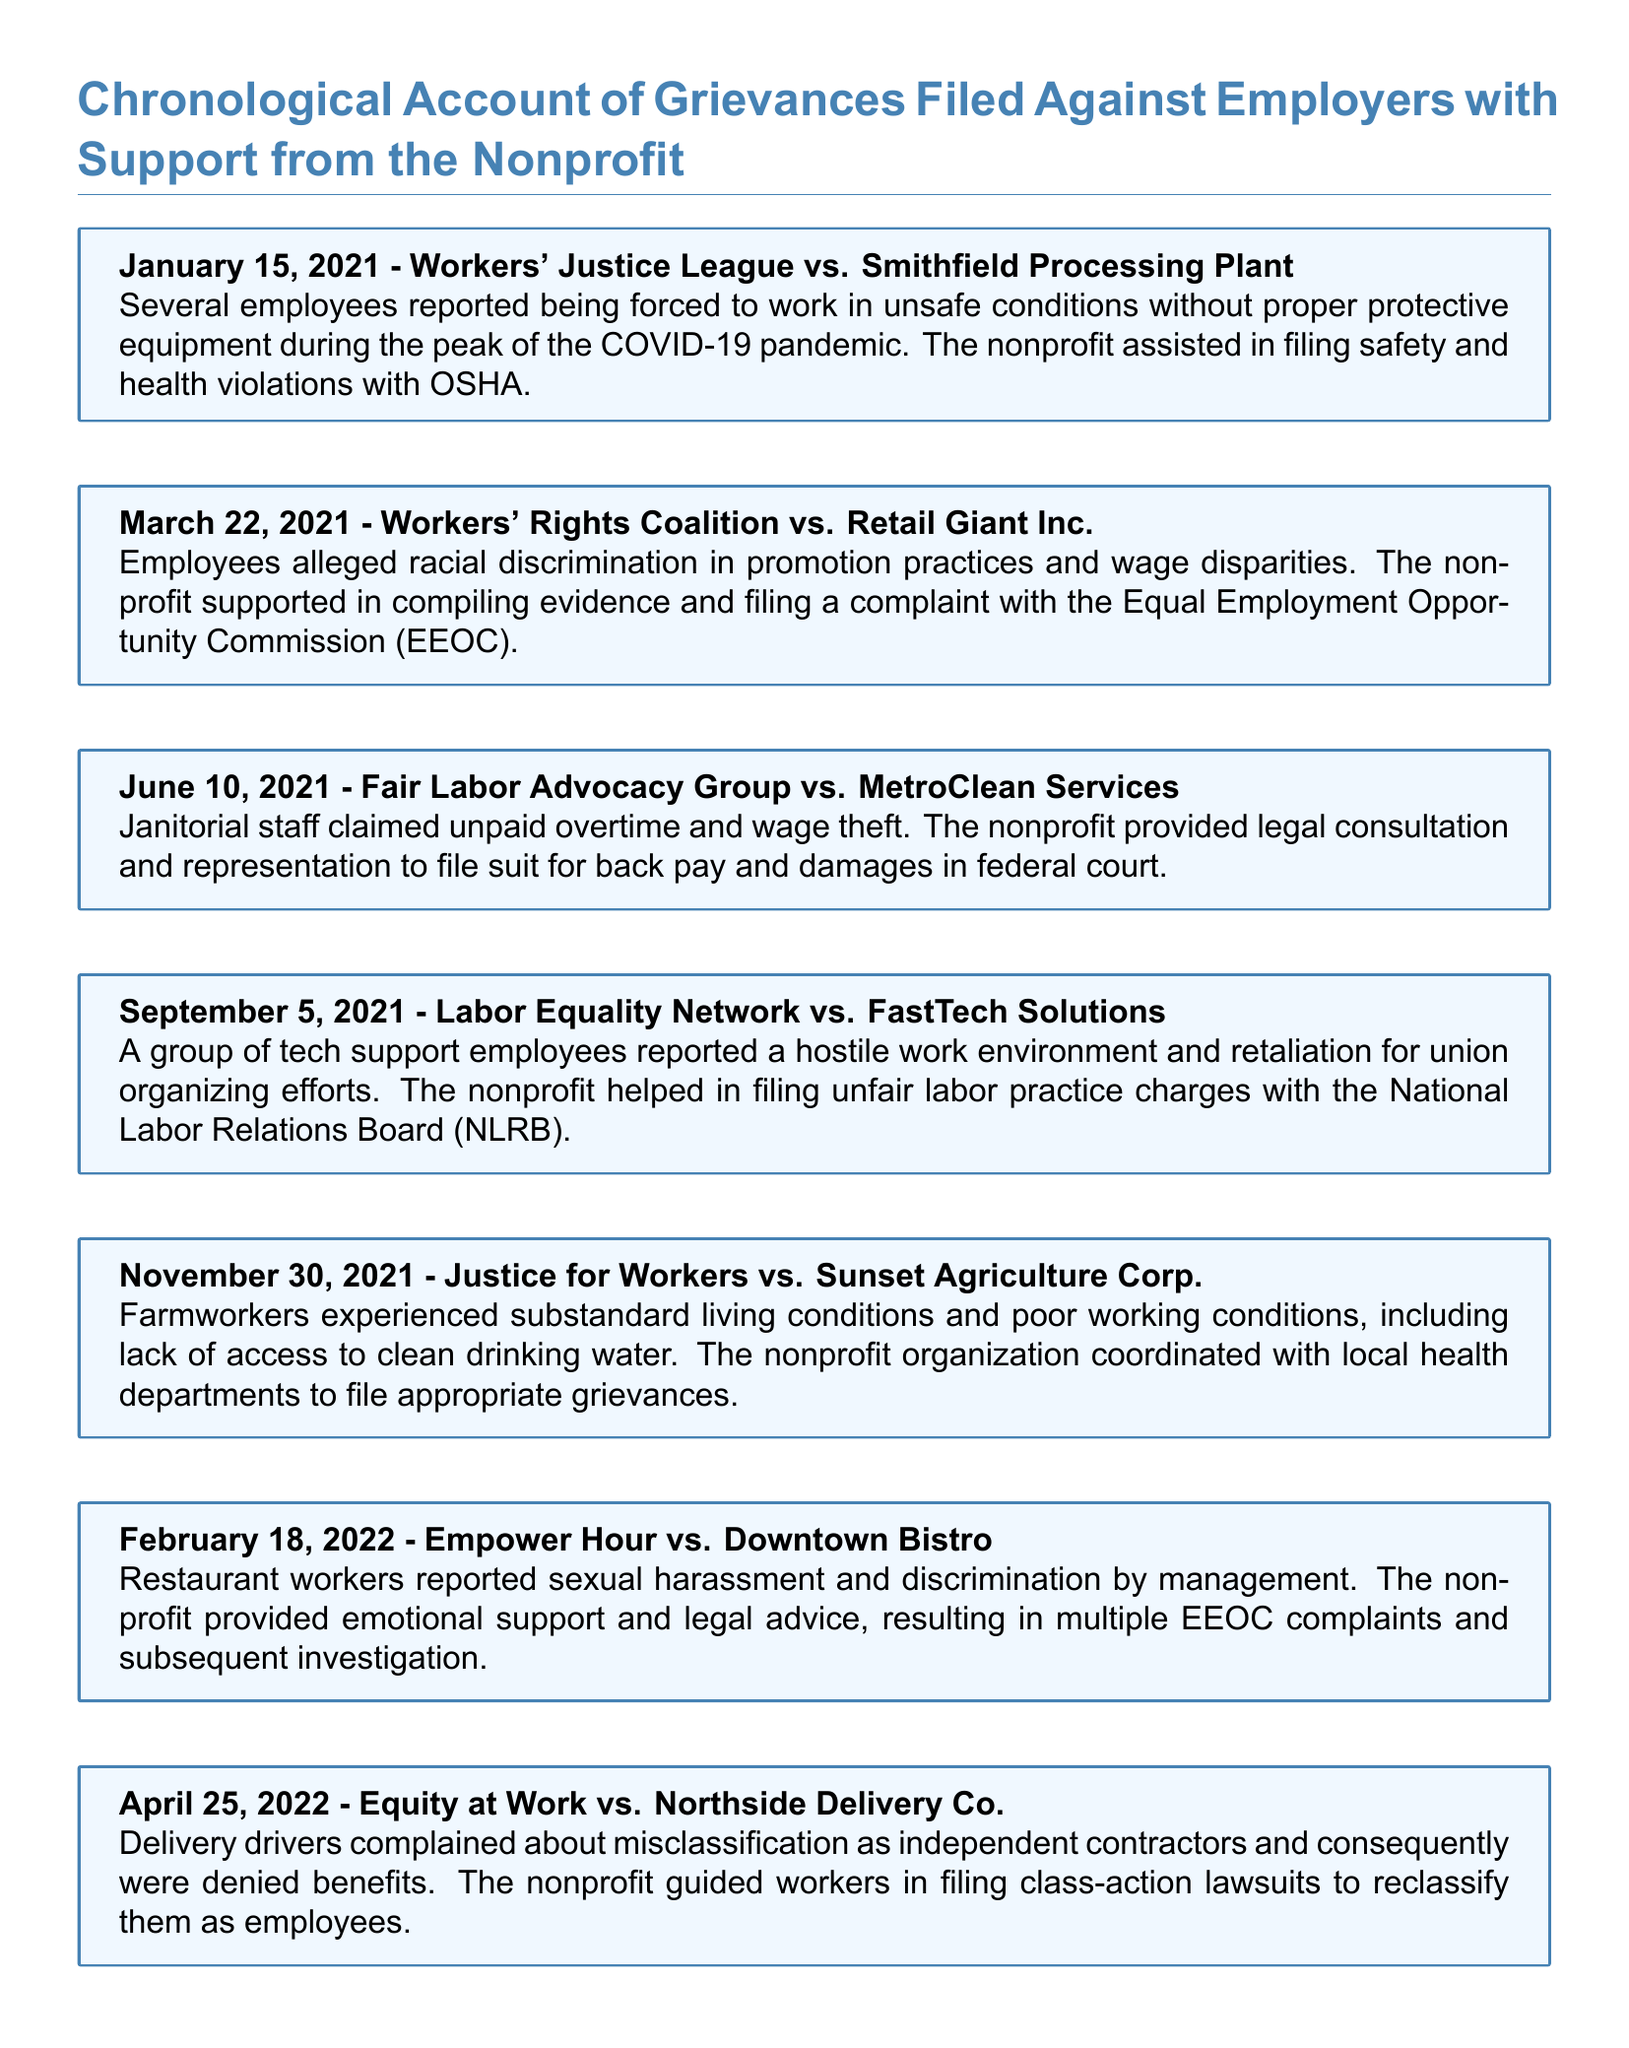what is the date of the grievance against Smithfield Processing Plant? The date is specified in the document under the title of the first grievance entry.
Answer: January 15, 2021 which nonprofit organization assisted in the grievance against Retail Giant Inc.? The document states that the Workers' Rights Coalition filed the grievance with support from a nonprofit organization.
Answer: Workers' Rights Coalition what issue was reported at MetroClean Services? The issue is detailed in the description of the grievance, highlighting the problem faced by janitorial staff.
Answer: unpaid overtime and wage theft how many grievances are reported in the document? The total number of grievances can be counted from the different entries in the document.
Answer: seven which employer did the delivery drivers file a grievance against? The document indicates the specific company involved in the grievance for delivery drivers under the appropriate entry.
Answer: Northside Delivery Co what type of complaint was filed against Downtown Bistro? The document specifies a serious issue experienced by restaurant workers in the mentioned grievance entry.
Answer: sexual harassment and discrimination which board was charged by FastTech Solutions employees? The nonprofit assisted in filing a complaint with an authority mentioned in the grievance entry.
Answer: National Labor Relations Board what was a key factor in the grievance filed against Sunset Agriculture Corp.? The document describes a specific condition that farmworkers experienced related to their working environment.
Answer: substandard living conditions 